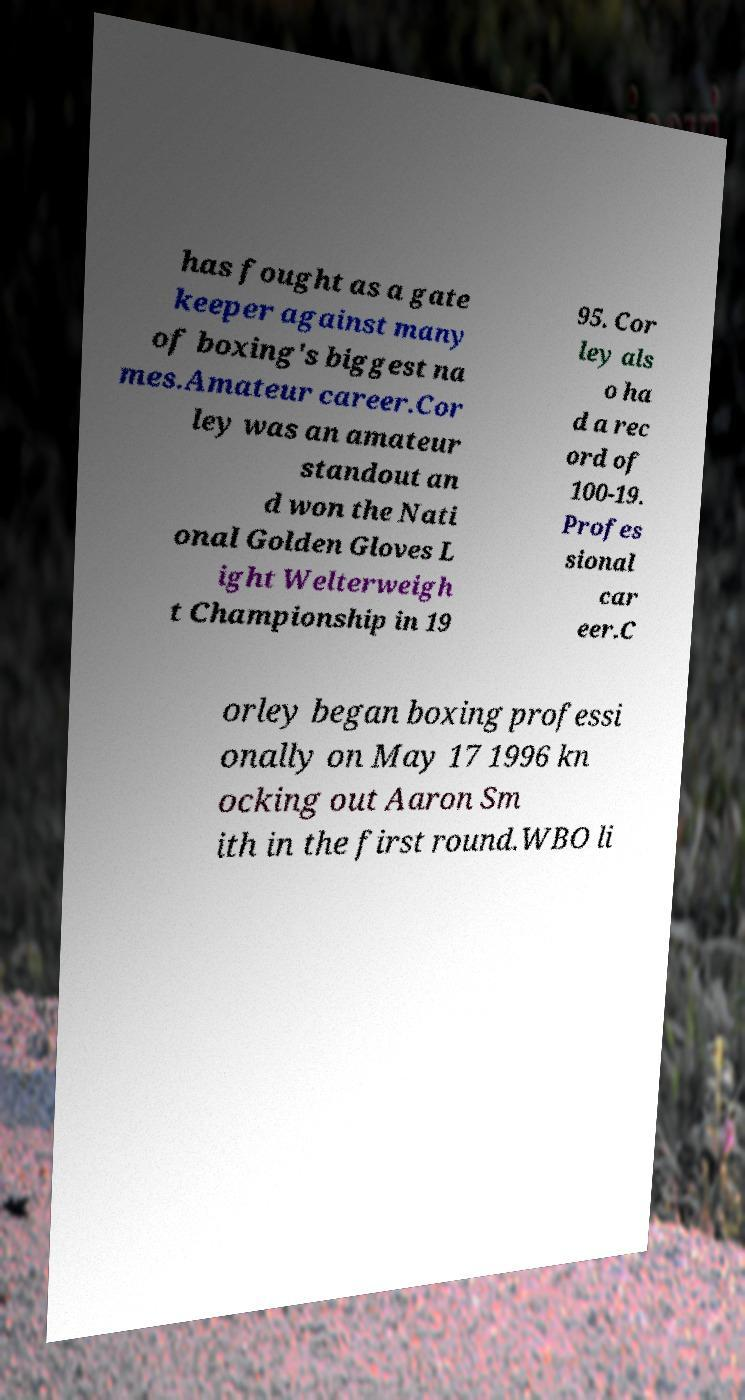Please identify and transcribe the text found in this image. has fought as a gate keeper against many of boxing's biggest na mes.Amateur career.Cor ley was an amateur standout an d won the Nati onal Golden Gloves L ight Welterweigh t Championship in 19 95. Cor ley als o ha d a rec ord of 100-19. Profes sional car eer.C orley began boxing professi onally on May 17 1996 kn ocking out Aaron Sm ith in the first round.WBO li 